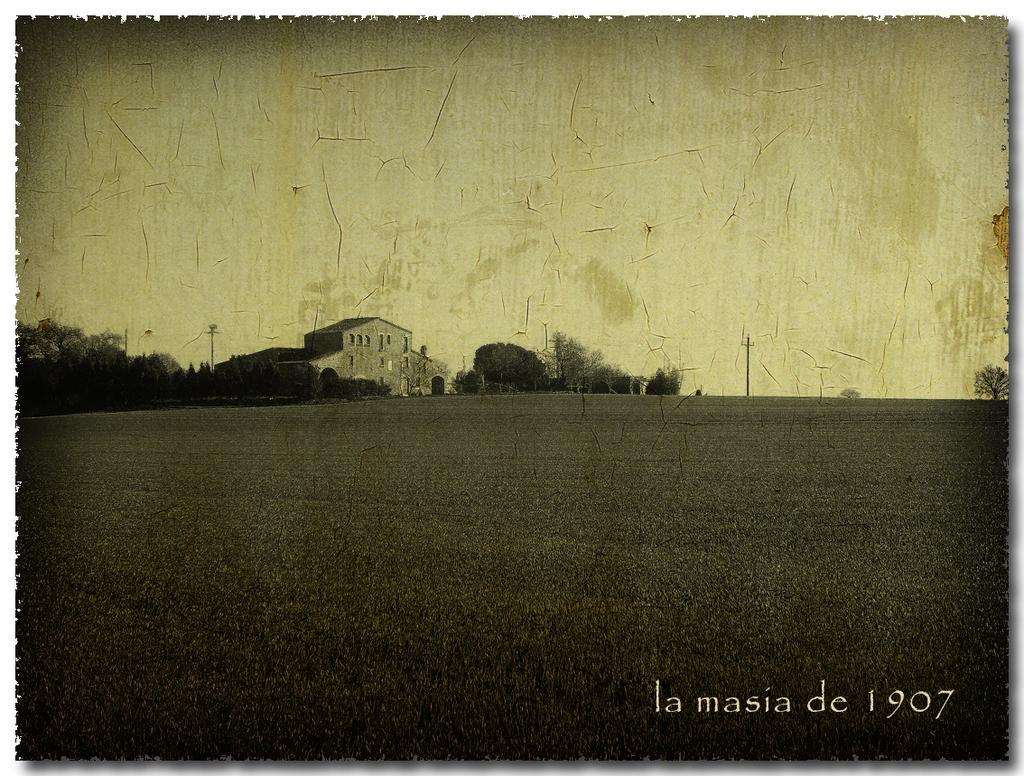What is the main subject of the poster in the image? The poster contains an image of a house. Are there any other elements in the poster besides the house? Yes, the poster contains images of trees and plants. What type of system is being used by the band in the image? There is no band present in the image, so it is not possible to determine what type of system they might be using. 